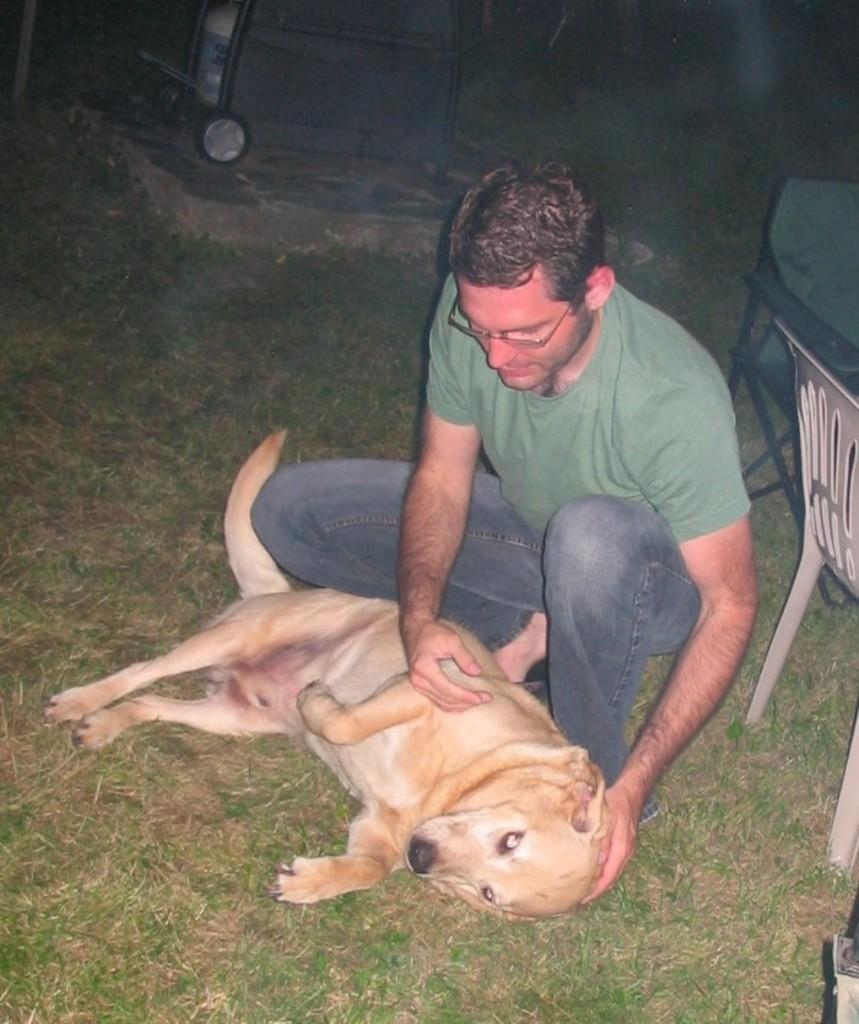Where is the location of the image? The image is outside of the city. What is the man in the image doing? The man is holding a dog in the image. What type of furniture is present in the image? There is a chair in the image. What type of vegetation can be seen in the image? There is grass in the image. How many frogs can be seen controlling the lift in the image? There are no frogs or lifts present in the image. What type of control does the man have over the dog in the image? The image does not show any specific control the man has over the dog; he is simply holding it. 